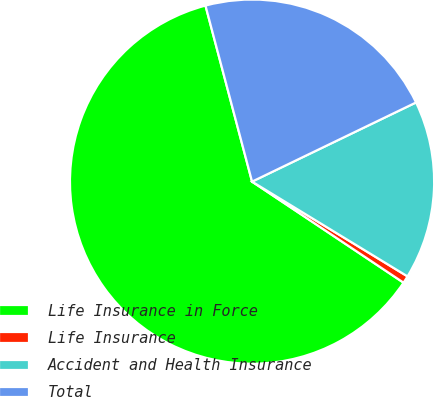<chart> <loc_0><loc_0><loc_500><loc_500><pie_chart><fcel>Life Insurance in Force<fcel>Life Insurance<fcel>Accident and Health Insurance<fcel>Total<nl><fcel>61.52%<fcel>0.65%<fcel>15.87%<fcel>21.96%<nl></chart> 